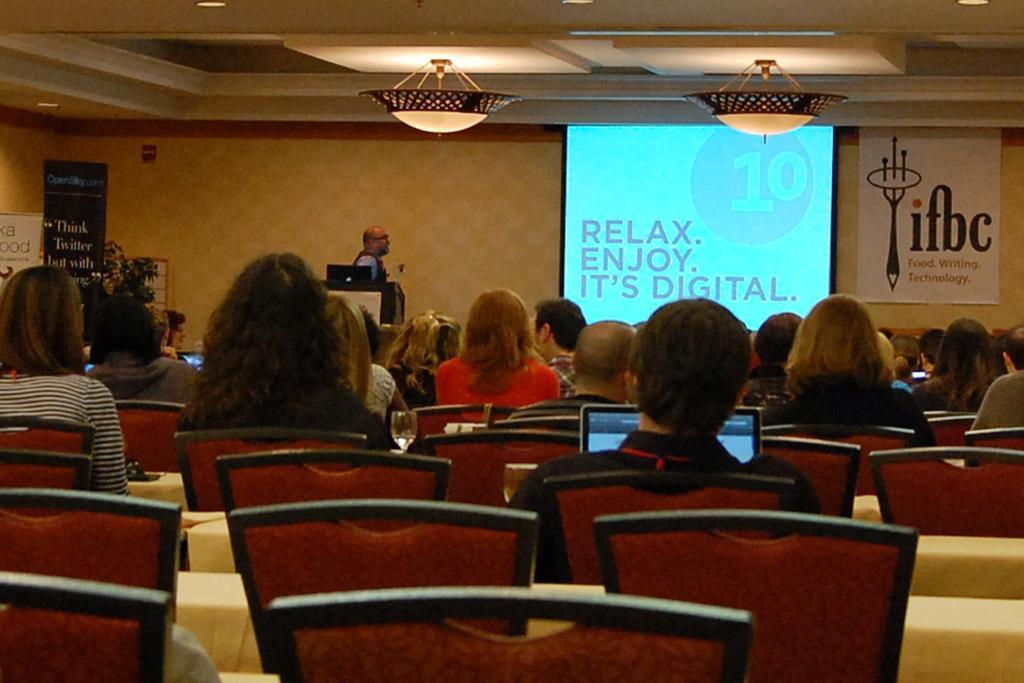Describe this image in one or two sentences. Screen and banner is on the wall. Lights are attached to the ceiling. In-front of this person there is a podium, above this podium there is a laptop. Here we can see hoardings and plant. These people are sitting on chairs, in-front of them there are tables. Above that tables there is a laptop, glass and things.  